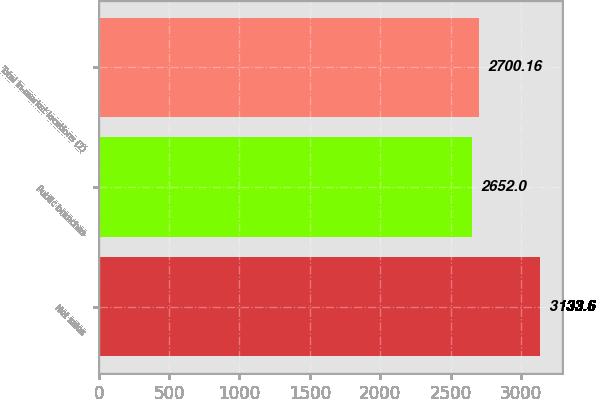<chart> <loc_0><loc_0><loc_500><loc_500><bar_chart><fcel>Net sales<fcel>Public branches<fcel>Total in-market locations (2)<nl><fcel>3133.6<fcel>2652<fcel>2700.16<nl></chart> 